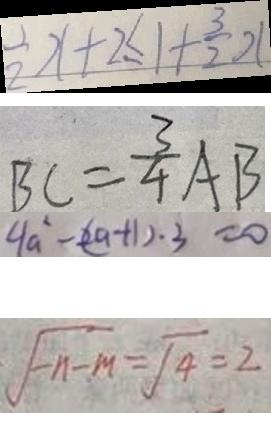Convert formula to latex. <formula><loc_0><loc_0><loc_500><loc_500>\frac { 1 } { 2 } x + 2 \leq 1 + \frac { 3 } { 2 } x 
 B C = \frac { 3 } { 4 } A B 
 4 a ^ { 2 } - ( 2 a + 1 ) \cdot 3 = 0 
 \sqrt { - n - M } = \sqrt { 4 } = 2</formula> 